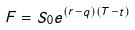<formula> <loc_0><loc_0><loc_500><loc_500>F = S _ { 0 } e ^ { ( r - q ) ( T - t ) }</formula> 